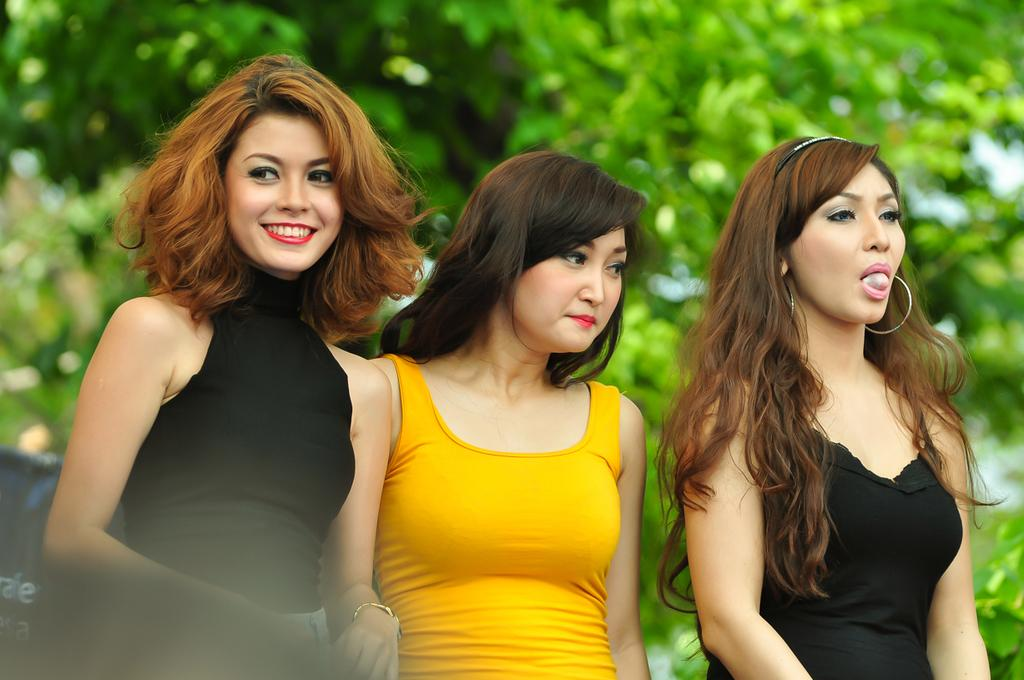How many people are in the image? There are three women in the image. What are the women doing in the image? The women are standing and smiling. What can be seen in the background of the image? There are trees visible in the background of the image. What type of scarf is the achiever wearing in the image? There is no achiever or scarf present in the image. Who is the partner of the woman on the left in the image? There is no partner mentioned or visible in the image. 